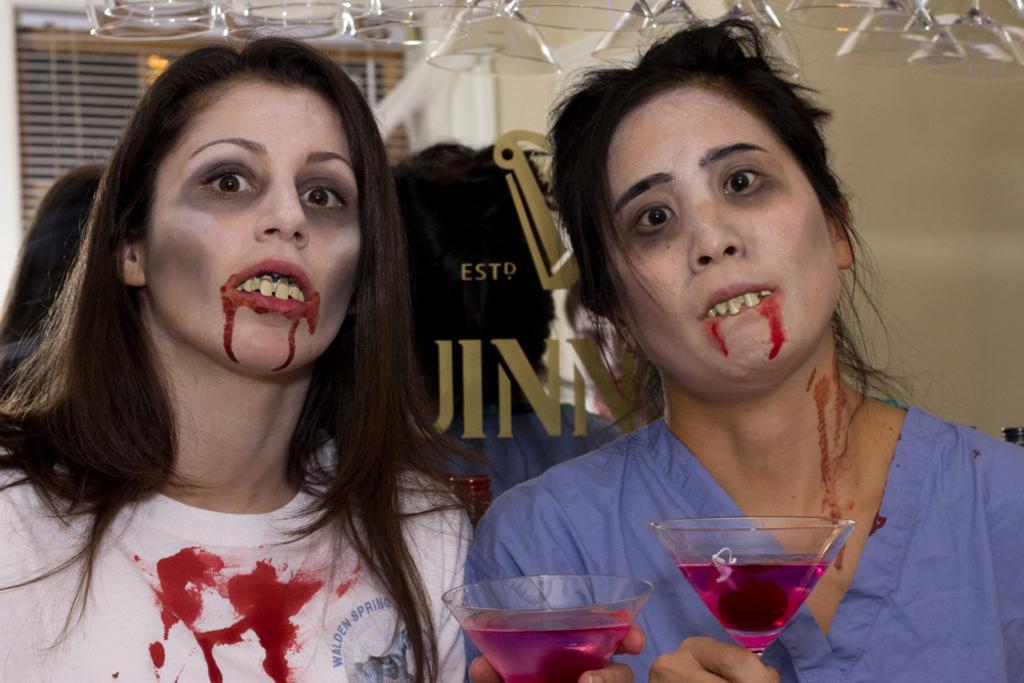In one or two sentences, can you explain what this image depicts? In this image I can see two women are holding glasses in their hands. The woman on the left is wearing white color T-shirt and the woman on the right side is wearing blue color clothes. In the background I can see some other objects. 